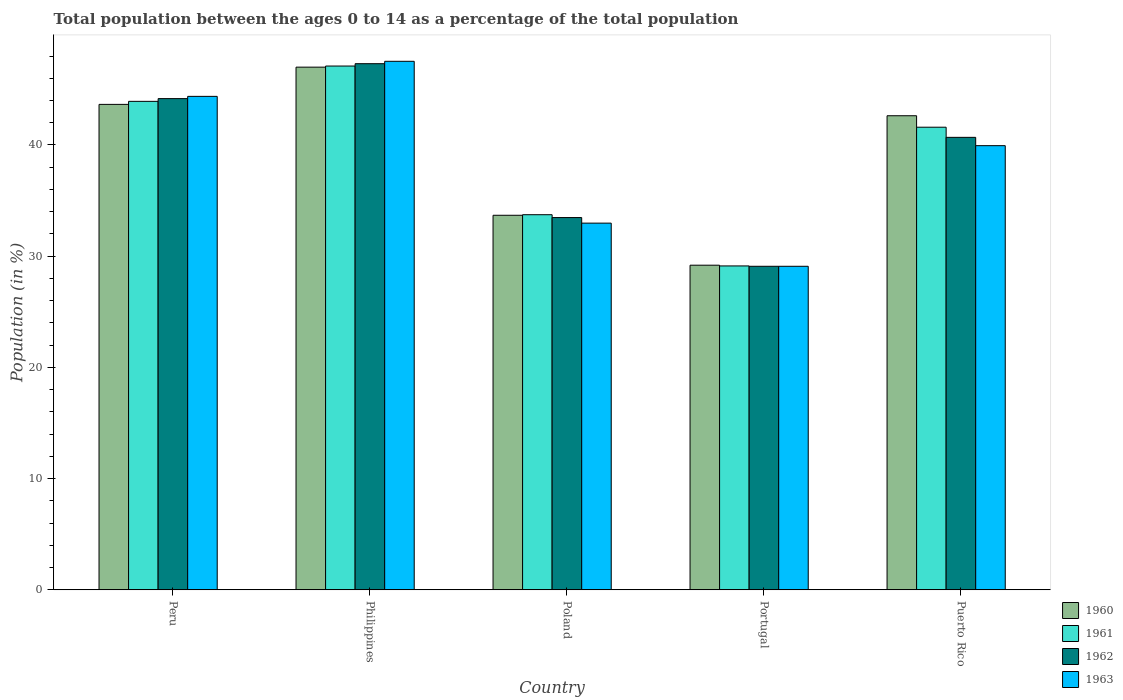How many different coloured bars are there?
Ensure brevity in your answer.  4. Are the number of bars per tick equal to the number of legend labels?
Keep it short and to the point. Yes. Are the number of bars on each tick of the X-axis equal?
Your answer should be compact. Yes. What is the label of the 1st group of bars from the left?
Your answer should be compact. Peru. In how many cases, is the number of bars for a given country not equal to the number of legend labels?
Provide a short and direct response. 0. What is the percentage of the population ages 0 to 14 in 1962 in Philippines?
Your answer should be very brief. 47.31. Across all countries, what is the maximum percentage of the population ages 0 to 14 in 1960?
Your answer should be compact. 47. Across all countries, what is the minimum percentage of the population ages 0 to 14 in 1961?
Ensure brevity in your answer.  29.13. In which country was the percentage of the population ages 0 to 14 in 1961 maximum?
Make the answer very short. Philippines. What is the total percentage of the population ages 0 to 14 in 1961 in the graph?
Provide a succinct answer. 195.48. What is the difference between the percentage of the population ages 0 to 14 in 1960 in Philippines and that in Portugal?
Give a very brief answer. 17.81. What is the difference between the percentage of the population ages 0 to 14 in 1960 in Puerto Rico and the percentage of the population ages 0 to 14 in 1963 in Peru?
Offer a very short reply. -1.74. What is the average percentage of the population ages 0 to 14 in 1962 per country?
Your response must be concise. 38.95. What is the difference between the percentage of the population ages 0 to 14 of/in 1963 and percentage of the population ages 0 to 14 of/in 1961 in Poland?
Provide a succinct answer. -0.76. In how many countries, is the percentage of the population ages 0 to 14 in 1960 greater than 10?
Give a very brief answer. 5. What is the ratio of the percentage of the population ages 0 to 14 in 1963 in Peru to that in Poland?
Make the answer very short. 1.35. Is the percentage of the population ages 0 to 14 in 1962 in Peru less than that in Portugal?
Give a very brief answer. No. What is the difference between the highest and the second highest percentage of the population ages 0 to 14 in 1963?
Ensure brevity in your answer.  4.43. What is the difference between the highest and the lowest percentage of the population ages 0 to 14 in 1963?
Ensure brevity in your answer.  18.43. What does the 4th bar from the left in Peru represents?
Your response must be concise. 1963. What does the 2nd bar from the right in Peru represents?
Ensure brevity in your answer.  1962. Is it the case that in every country, the sum of the percentage of the population ages 0 to 14 in 1962 and percentage of the population ages 0 to 14 in 1961 is greater than the percentage of the population ages 0 to 14 in 1963?
Give a very brief answer. Yes. What is the difference between two consecutive major ticks on the Y-axis?
Keep it short and to the point. 10. Are the values on the major ticks of Y-axis written in scientific E-notation?
Your response must be concise. No. Does the graph contain any zero values?
Give a very brief answer. No. Where does the legend appear in the graph?
Keep it short and to the point. Bottom right. How are the legend labels stacked?
Offer a very short reply. Vertical. What is the title of the graph?
Make the answer very short. Total population between the ages 0 to 14 as a percentage of the total population. Does "2011" appear as one of the legend labels in the graph?
Offer a very short reply. No. What is the label or title of the Y-axis?
Offer a terse response. Population (in %). What is the Population (in %) in 1960 in Peru?
Your answer should be very brief. 43.65. What is the Population (in %) in 1961 in Peru?
Give a very brief answer. 43.92. What is the Population (in %) in 1962 in Peru?
Ensure brevity in your answer.  44.17. What is the Population (in %) of 1963 in Peru?
Offer a terse response. 44.37. What is the Population (in %) in 1960 in Philippines?
Ensure brevity in your answer.  47. What is the Population (in %) of 1961 in Philippines?
Offer a very short reply. 47.1. What is the Population (in %) of 1962 in Philippines?
Make the answer very short. 47.31. What is the Population (in %) of 1963 in Philippines?
Make the answer very short. 47.53. What is the Population (in %) of 1960 in Poland?
Your answer should be compact. 33.68. What is the Population (in %) in 1961 in Poland?
Your answer should be compact. 33.73. What is the Population (in %) in 1962 in Poland?
Offer a terse response. 33.47. What is the Population (in %) in 1963 in Poland?
Offer a terse response. 32.97. What is the Population (in %) in 1960 in Portugal?
Offer a terse response. 29.19. What is the Population (in %) in 1961 in Portugal?
Offer a terse response. 29.13. What is the Population (in %) in 1962 in Portugal?
Provide a succinct answer. 29.09. What is the Population (in %) in 1963 in Portugal?
Your response must be concise. 29.09. What is the Population (in %) of 1960 in Puerto Rico?
Your answer should be very brief. 42.63. What is the Population (in %) in 1961 in Puerto Rico?
Give a very brief answer. 41.6. What is the Population (in %) in 1962 in Puerto Rico?
Offer a very short reply. 40.69. What is the Population (in %) of 1963 in Puerto Rico?
Make the answer very short. 39.94. Across all countries, what is the maximum Population (in %) in 1960?
Make the answer very short. 47. Across all countries, what is the maximum Population (in %) of 1961?
Offer a very short reply. 47.1. Across all countries, what is the maximum Population (in %) in 1962?
Provide a short and direct response. 47.31. Across all countries, what is the maximum Population (in %) in 1963?
Your response must be concise. 47.53. Across all countries, what is the minimum Population (in %) of 1960?
Provide a succinct answer. 29.19. Across all countries, what is the minimum Population (in %) in 1961?
Ensure brevity in your answer.  29.13. Across all countries, what is the minimum Population (in %) in 1962?
Your response must be concise. 29.09. Across all countries, what is the minimum Population (in %) in 1963?
Offer a terse response. 29.09. What is the total Population (in %) of 1960 in the graph?
Keep it short and to the point. 196.16. What is the total Population (in %) in 1961 in the graph?
Your response must be concise. 195.48. What is the total Population (in %) in 1962 in the graph?
Your answer should be very brief. 194.74. What is the total Population (in %) in 1963 in the graph?
Your answer should be very brief. 193.91. What is the difference between the Population (in %) in 1960 in Peru and that in Philippines?
Offer a terse response. -3.35. What is the difference between the Population (in %) of 1961 in Peru and that in Philippines?
Offer a very short reply. -3.18. What is the difference between the Population (in %) in 1962 in Peru and that in Philippines?
Ensure brevity in your answer.  -3.14. What is the difference between the Population (in %) of 1963 in Peru and that in Philippines?
Keep it short and to the point. -3.15. What is the difference between the Population (in %) in 1960 in Peru and that in Poland?
Make the answer very short. 9.97. What is the difference between the Population (in %) of 1961 in Peru and that in Poland?
Make the answer very short. 10.19. What is the difference between the Population (in %) of 1962 in Peru and that in Poland?
Give a very brief answer. 10.7. What is the difference between the Population (in %) of 1963 in Peru and that in Poland?
Provide a short and direct response. 11.4. What is the difference between the Population (in %) of 1960 in Peru and that in Portugal?
Offer a very short reply. 14.46. What is the difference between the Population (in %) of 1961 in Peru and that in Portugal?
Your answer should be compact. 14.8. What is the difference between the Population (in %) of 1962 in Peru and that in Portugal?
Provide a succinct answer. 15.08. What is the difference between the Population (in %) of 1963 in Peru and that in Portugal?
Ensure brevity in your answer.  15.28. What is the difference between the Population (in %) of 1960 in Peru and that in Puerto Rico?
Ensure brevity in your answer.  1.02. What is the difference between the Population (in %) of 1961 in Peru and that in Puerto Rico?
Your answer should be compact. 2.33. What is the difference between the Population (in %) in 1962 in Peru and that in Puerto Rico?
Ensure brevity in your answer.  3.48. What is the difference between the Population (in %) of 1963 in Peru and that in Puerto Rico?
Ensure brevity in your answer.  4.43. What is the difference between the Population (in %) in 1960 in Philippines and that in Poland?
Offer a terse response. 13.32. What is the difference between the Population (in %) in 1961 in Philippines and that in Poland?
Your answer should be very brief. 13.37. What is the difference between the Population (in %) of 1962 in Philippines and that in Poland?
Provide a short and direct response. 13.84. What is the difference between the Population (in %) in 1963 in Philippines and that in Poland?
Offer a terse response. 14.55. What is the difference between the Population (in %) in 1960 in Philippines and that in Portugal?
Ensure brevity in your answer.  17.81. What is the difference between the Population (in %) in 1961 in Philippines and that in Portugal?
Keep it short and to the point. 17.97. What is the difference between the Population (in %) in 1962 in Philippines and that in Portugal?
Ensure brevity in your answer.  18.22. What is the difference between the Population (in %) in 1963 in Philippines and that in Portugal?
Ensure brevity in your answer.  18.43. What is the difference between the Population (in %) of 1960 in Philippines and that in Puerto Rico?
Your answer should be compact. 4.37. What is the difference between the Population (in %) of 1961 in Philippines and that in Puerto Rico?
Your answer should be compact. 5.5. What is the difference between the Population (in %) of 1962 in Philippines and that in Puerto Rico?
Offer a very short reply. 6.62. What is the difference between the Population (in %) of 1963 in Philippines and that in Puerto Rico?
Your answer should be very brief. 7.59. What is the difference between the Population (in %) of 1960 in Poland and that in Portugal?
Ensure brevity in your answer.  4.49. What is the difference between the Population (in %) of 1961 in Poland and that in Portugal?
Your answer should be compact. 4.61. What is the difference between the Population (in %) of 1962 in Poland and that in Portugal?
Your answer should be very brief. 4.38. What is the difference between the Population (in %) in 1963 in Poland and that in Portugal?
Provide a short and direct response. 3.88. What is the difference between the Population (in %) of 1960 in Poland and that in Puerto Rico?
Your answer should be very brief. -8.95. What is the difference between the Population (in %) in 1961 in Poland and that in Puerto Rico?
Offer a terse response. -7.87. What is the difference between the Population (in %) in 1962 in Poland and that in Puerto Rico?
Your response must be concise. -7.21. What is the difference between the Population (in %) in 1963 in Poland and that in Puerto Rico?
Keep it short and to the point. -6.97. What is the difference between the Population (in %) in 1960 in Portugal and that in Puerto Rico?
Your response must be concise. -13.44. What is the difference between the Population (in %) in 1961 in Portugal and that in Puerto Rico?
Give a very brief answer. -12.47. What is the difference between the Population (in %) in 1962 in Portugal and that in Puerto Rico?
Give a very brief answer. -11.59. What is the difference between the Population (in %) in 1963 in Portugal and that in Puerto Rico?
Offer a terse response. -10.85. What is the difference between the Population (in %) of 1960 in Peru and the Population (in %) of 1961 in Philippines?
Your response must be concise. -3.45. What is the difference between the Population (in %) in 1960 in Peru and the Population (in %) in 1962 in Philippines?
Provide a succinct answer. -3.66. What is the difference between the Population (in %) of 1960 in Peru and the Population (in %) of 1963 in Philippines?
Give a very brief answer. -3.87. What is the difference between the Population (in %) in 1961 in Peru and the Population (in %) in 1962 in Philippines?
Offer a terse response. -3.39. What is the difference between the Population (in %) of 1961 in Peru and the Population (in %) of 1963 in Philippines?
Your response must be concise. -3.6. What is the difference between the Population (in %) of 1962 in Peru and the Population (in %) of 1963 in Philippines?
Your answer should be compact. -3.36. What is the difference between the Population (in %) in 1960 in Peru and the Population (in %) in 1961 in Poland?
Provide a succinct answer. 9.92. What is the difference between the Population (in %) in 1960 in Peru and the Population (in %) in 1962 in Poland?
Provide a succinct answer. 10.18. What is the difference between the Population (in %) of 1960 in Peru and the Population (in %) of 1963 in Poland?
Provide a short and direct response. 10.68. What is the difference between the Population (in %) of 1961 in Peru and the Population (in %) of 1962 in Poland?
Your response must be concise. 10.45. What is the difference between the Population (in %) of 1961 in Peru and the Population (in %) of 1963 in Poland?
Make the answer very short. 10.95. What is the difference between the Population (in %) of 1962 in Peru and the Population (in %) of 1963 in Poland?
Make the answer very short. 11.2. What is the difference between the Population (in %) in 1960 in Peru and the Population (in %) in 1961 in Portugal?
Keep it short and to the point. 14.53. What is the difference between the Population (in %) in 1960 in Peru and the Population (in %) in 1962 in Portugal?
Your response must be concise. 14.56. What is the difference between the Population (in %) of 1960 in Peru and the Population (in %) of 1963 in Portugal?
Keep it short and to the point. 14.56. What is the difference between the Population (in %) in 1961 in Peru and the Population (in %) in 1962 in Portugal?
Your answer should be compact. 14.83. What is the difference between the Population (in %) of 1961 in Peru and the Population (in %) of 1963 in Portugal?
Offer a very short reply. 14.83. What is the difference between the Population (in %) of 1962 in Peru and the Population (in %) of 1963 in Portugal?
Your answer should be compact. 15.08. What is the difference between the Population (in %) of 1960 in Peru and the Population (in %) of 1961 in Puerto Rico?
Your answer should be very brief. 2.05. What is the difference between the Population (in %) of 1960 in Peru and the Population (in %) of 1962 in Puerto Rico?
Your answer should be very brief. 2.96. What is the difference between the Population (in %) of 1960 in Peru and the Population (in %) of 1963 in Puerto Rico?
Offer a terse response. 3.71. What is the difference between the Population (in %) of 1961 in Peru and the Population (in %) of 1962 in Puerto Rico?
Offer a very short reply. 3.24. What is the difference between the Population (in %) in 1961 in Peru and the Population (in %) in 1963 in Puerto Rico?
Your response must be concise. 3.98. What is the difference between the Population (in %) in 1962 in Peru and the Population (in %) in 1963 in Puerto Rico?
Offer a very short reply. 4.23. What is the difference between the Population (in %) in 1960 in Philippines and the Population (in %) in 1961 in Poland?
Provide a succinct answer. 13.27. What is the difference between the Population (in %) of 1960 in Philippines and the Population (in %) of 1962 in Poland?
Make the answer very short. 13.53. What is the difference between the Population (in %) in 1960 in Philippines and the Population (in %) in 1963 in Poland?
Your answer should be compact. 14.03. What is the difference between the Population (in %) of 1961 in Philippines and the Population (in %) of 1962 in Poland?
Offer a terse response. 13.63. What is the difference between the Population (in %) in 1961 in Philippines and the Population (in %) in 1963 in Poland?
Your answer should be very brief. 14.13. What is the difference between the Population (in %) of 1962 in Philippines and the Population (in %) of 1963 in Poland?
Ensure brevity in your answer.  14.34. What is the difference between the Population (in %) in 1960 in Philippines and the Population (in %) in 1961 in Portugal?
Make the answer very short. 17.88. What is the difference between the Population (in %) of 1960 in Philippines and the Population (in %) of 1962 in Portugal?
Your answer should be very brief. 17.91. What is the difference between the Population (in %) in 1960 in Philippines and the Population (in %) in 1963 in Portugal?
Give a very brief answer. 17.91. What is the difference between the Population (in %) of 1961 in Philippines and the Population (in %) of 1962 in Portugal?
Ensure brevity in your answer.  18.01. What is the difference between the Population (in %) in 1961 in Philippines and the Population (in %) in 1963 in Portugal?
Offer a terse response. 18.01. What is the difference between the Population (in %) in 1962 in Philippines and the Population (in %) in 1963 in Portugal?
Your answer should be compact. 18.22. What is the difference between the Population (in %) in 1960 in Philippines and the Population (in %) in 1961 in Puerto Rico?
Your answer should be compact. 5.4. What is the difference between the Population (in %) in 1960 in Philippines and the Population (in %) in 1962 in Puerto Rico?
Offer a terse response. 6.31. What is the difference between the Population (in %) of 1960 in Philippines and the Population (in %) of 1963 in Puerto Rico?
Provide a succinct answer. 7.06. What is the difference between the Population (in %) of 1961 in Philippines and the Population (in %) of 1962 in Puerto Rico?
Provide a succinct answer. 6.41. What is the difference between the Population (in %) in 1961 in Philippines and the Population (in %) in 1963 in Puerto Rico?
Provide a succinct answer. 7.16. What is the difference between the Population (in %) in 1962 in Philippines and the Population (in %) in 1963 in Puerto Rico?
Your answer should be compact. 7.37. What is the difference between the Population (in %) in 1960 in Poland and the Population (in %) in 1961 in Portugal?
Your answer should be very brief. 4.56. What is the difference between the Population (in %) in 1960 in Poland and the Population (in %) in 1962 in Portugal?
Provide a succinct answer. 4.59. What is the difference between the Population (in %) of 1960 in Poland and the Population (in %) of 1963 in Portugal?
Offer a terse response. 4.59. What is the difference between the Population (in %) in 1961 in Poland and the Population (in %) in 1962 in Portugal?
Offer a very short reply. 4.64. What is the difference between the Population (in %) in 1961 in Poland and the Population (in %) in 1963 in Portugal?
Offer a very short reply. 4.64. What is the difference between the Population (in %) in 1962 in Poland and the Population (in %) in 1963 in Portugal?
Your answer should be compact. 4.38. What is the difference between the Population (in %) of 1960 in Poland and the Population (in %) of 1961 in Puerto Rico?
Your response must be concise. -7.92. What is the difference between the Population (in %) in 1960 in Poland and the Population (in %) in 1962 in Puerto Rico?
Your answer should be compact. -7.01. What is the difference between the Population (in %) in 1960 in Poland and the Population (in %) in 1963 in Puerto Rico?
Provide a short and direct response. -6.26. What is the difference between the Population (in %) of 1961 in Poland and the Population (in %) of 1962 in Puerto Rico?
Your answer should be compact. -6.96. What is the difference between the Population (in %) in 1961 in Poland and the Population (in %) in 1963 in Puerto Rico?
Offer a terse response. -6.21. What is the difference between the Population (in %) of 1962 in Poland and the Population (in %) of 1963 in Puerto Rico?
Offer a very short reply. -6.47. What is the difference between the Population (in %) in 1960 in Portugal and the Population (in %) in 1961 in Puerto Rico?
Offer a terse response. -12.41. What is the difference between the Population (in %) in 1960 in Portugal and the Population (in %) in 1962 in Puerto Rico?
Your answer should be compact. -11.5. What is the difference between the Population (in %) of 1960 in Portugal and the Population (in %) of 1963 in Puerto Rico?
Provide a short and direct response. -10.75. What is the difference between the Population (in %) in 1961 in Portugal and the Population (in %) in 1962 in Puerto Rico?
Your answer should be compact. -11.56. What is the difference between the Population (in %) in 1961 in Portugal and the Population (in %) in 1963 in Puerto Rico?
Give a very brief answer. -10.81. What is the difference between the Population (in %) of 1962 in Portugal and the Population (in %) of 1963 in Puerto Rico?
Keep it short and to the point. -10.85. What is the average Population (in %) in 1960 per country?
Provide a short and direct response. 39.23. What is the average Population (in %) in 1961 per country?
Ensure brevity in your answer.  39.1. What is the average Population (in %) in 1962 per country?
Your response must be concise. 38.95. What is the average Population (in %) of 1963 per country?
Your answer should be compact. 38.78. What is the difference between the Population (in %) in 1960 and Population (in %) in 1961 in Peru?
Ensure brevity in your answer.  -0.27. What is the difference between the Population (in %) of 1960 and Population (in %) of 1962 in Peru?
Ensure brevity in your answer.  -0.52. What is the difference between the Population (in %) in 1960 and Population (in %) in 1963 in Peru?
Provide a short and direct response. -0.72. What is the difference between the Population (in %) in 1961 and Population (in %) in 1962 in Peru?
Give a very brief answer. -0.25. What is the difference between the Population (in %) in 1961 and Population (in %) in 1963 in Peru?
Your answer should be very brief. -0.45. What is the difference between the Population (in %) in 1962 and Population (in %) in 1963 in Peru?
Provide a short and direct response. -0.2. What is the difference between the Population (in %) in 1960 and Population (in %) in 1961 in Philippines?
Provide a short and direct response. -0.1. What is the difference between the Population (in %) in 1960 and Population (in %) in 1962 in Philippines?
Your response must be concise. -0.31. What is the difference between the Population (in %) in 1960 and Population (in %) in 1963 in Philippines?
Keep it short and to the point. -0.53. What is the difference between the Population (in %) in 1961 and Population (in %) in 1962 in Philippines?
Your response must be concise. -0.21. What is the difference between the Population (in %) of 1961 and Population (in %) of 1963 in Philippines?
Keep it short and to the point. -0.43. What is the difference between the Population (in %) in 1962 and Population (in %) in 1963 in Philippines?
Offer a very short reply. -0.21. What is the difference between the Population (in %) in 1960 and Population (in %) in 1961 in Poland?
Ensure brevity in your answer.  -0.05. What is the difference between the Population (in %) in 1960 and Population (in %) in 1962 in Poland?
Make the answer very short. 0.21. What is the difference between the Population (in %) in 1960 and Population (in %) in 1963 in Poland?
Your answer should be very brief. 0.71. What is the difference between the Population (in %) in 1961 and Population (in %) in 1962 in Poland?
Your answer should be compact. 0.26. What is the difference between the Population (in %) in 1961 and Population (in %) in 1963 in Poland?
Offer a terse response. 0.76. What is the difference between the Population (in %) in 1962 and Population (in %) in 1963 in Poland?
Offer a very short reply. 0.5. What is the difference between the Population (in %) in 1960 and Population (in %) in 1961 in Portugal?
Offer a terse response. 0.07. What is the difference between the Population (in %) in 1960 and Population (in %) in 1962 in Portugal?
Offer a very short reply. 0.1. What is the difference between the Population (in %) in 1960 and Population (in %) in 1963 in Portugal?
Keep it short and to the point. 0.1. What is the difference between the Population (in %) in 1961 and Population (in %) in 1962 in Portugal?
Make the answer very short. 0.03. What is the difference between the Population (in %) of 1961 and Population (in %) of 1963 in Portugal?
Keep it short and to the point. 0.03. What is the difference between the Population (in %) of 1962 and Population (in %) of 1963 in Portugal?
Keep it short and to the point. 0. What is the difference between the Population (in %) of 1960 and Population (in %) of 1961 in Puerto Rico?
Provide a short and direct response. 1.03. What is the difference between the Population (in %) in 1960 and Population (in %) in 1962 in Puerto Rico?
Keep it short and to the point. 1.94. What is the difference between the Population (in %) in 1960 and Population (in %) in 1963 in Puerto Rico?
Ensure brevity in your answer.  2.69. What is the difference between the Population (in %) of 1961 and Population (in %) of 1962 in Puerto Rico?
Provide a succinct answer. 0.91. What is the difference between the Population (in %) of 1961 and Population (in %) of 1963 in Puerto Rico?
Your answer should be compact. 1.66. What is the difference between the Population (in %) in 1962 and Population (in %) in 1963 in Puerto Rico?
Your answer should be very brief. 0.75. What is the ratio of the Population (in %) of 1960 in Peru to that in Philippines?
Provide a succinct answer. 0.93. What is the ratio of the Population (in %) of 1961 in Peru to that in Philippines?
Offer a terse response. 0.93. What is the ratio of the Population (in %) of 1962 in Peru to that in Philippines?
Your response must be concise. 0.93. What is the ratio of the Population (in %) of 1963 in Peru to that in Philippines?
Make the answer very short. 0.93. What is the ratio of the Population (in %) of 1960 in Peru to that in Poland?
Provide a succinct answer. 1.3. What is the ratio of the Population (in %) in 1961 in Peru to that in Poland?
Provide a succinct answer. 1.3. What is the ratio of the Population (in %) in 1962 in Peru to that in Poland?
Provide a short and direct response. 1.32. What is the ratio of the Population (in %) of 1963 in Peru to that in Poland?
Keep it short and to the point. 1.35. What is the ratio of the Population (in %) in 1960 in Peru to that in Portugal?
Provide a short and direct response. 1.5. What is the ratio of the Population (in %) in 1961 in Peru to that in Portugal?
Your response must be concise. 1.51. What is the ratio of the Population (in %) of 1962 in Peru to that in Portugal?
Provide a short and direct response. 1.52. What is the ratio of the Population (in %) of 1963 in Peru to that in Portugal?
Provide a short and direct response. 1.53. What is the ratio of the Population (in %) in 1961 in Peru to that in Puerto Rico?
Your answer should be very brief. 1.06. What is the ratio of the Population (in %) of 1962 in Peru to that in Puerto Rico?
Provide a succinct answer. 1.09. What is the ratio of the Population (in %) of 1963 in Peru to that in Puerto Rico?
Provide a short and direct response. 1.11. What is the ratio of the Population (in %) of 1960 in Philippines to that in Poland?
Your answer should be very brief. 1.4. What is the ratio of the Population (in %) of 1961 in Philippines to that in Poland?
Offer a terse response. 1.4. What is the ratio of the Population (in %) of 1962 in Philippines to that in Poland?
Offer a very short reply. 1.41. What is the ratio of the Population (in %) of 1963 in Philippines to that in Poland?
Offer a terse response. 1.44. What is the ratio of the Population (in %) in 1960 in Philippines to that in Portugal?
Ensure brevity in your answer.  1.61. What is the ratio of the Population (in %) in 1961 in Philippines to that in Portugal?
Make the answer very short. 1.62. What is the ratio of the Population (in %) in 1962 in Philippines to that in Portugal?
Ensure brevity in your answer.  1.63. What is the ratio of the Population (in %) of 1963 in Philippines to that in Portugal?
Your answer should be compact. 1.63. What is the ratio of the Population (in %) of 1960 in Philippines to that in Puerto Rico?
Keep it short and to the point. 1.1. What is the ratio of the Population (in %) in 1961 in Philippines to that in Puerto Rico?
Keep it short and to the point. 1.13. What is the ratio of the Population (in %) of 1962 in Philippines to that in Puerto Rico?
Offer a terse response. 1.16. What is the ratio of the Population (in %) of 1963 in Philippines to that in Puerto Rico?
Provide a succinct answer. 1.19. What is the ratio of the Population (in %) of 1960 in Poland to that in Portugal?
Ensure brevity in your answer.  1.15. What is the ratio of the Population (in %) of 1961 in Poland to that in Portugal?
Your response must be concise. 1.16. What is the ratio of the Population (in %) of 1962 in Poland to that in Portugal?
Give a very brief answer. 1.15. What is the ratio of the Population (in %) in 1963 in Poland to that in Portugal?
Keep it short and to the point. 1.13. What is the ratio of the Population (in %) of 1960 in Poland to that in Puerto Rico?
Give a very brief answer. 0.79. What is the ratio of the Population (in %) of 1961 in Poland to that in Puerto Rico?
Give a very brief answer. 0.81. What is the ratio of the Population (in %) in 1962 in Poland to that in Puerto Rico?
Give a very brief answer. 0.82. What is the ratio of the Population (in %) in 1963 in Poland to that in Puerto Rico?
Ensure brevity in your answer.  0.83. What is the ratio of the Population (in %) in 1960 in Portugal to that in Puerto Rico?
Ensure brevity in your answer.  0.68. What is the ratio of the Population (in %) of 1961 in Portugal to that in Puerto Rico?
Provide a short and direct response. 0.7. What is the ratio of the Population (in %) in 1962 in Portugal to that in Puerto Rico?
Keep it short and to the point. 0.71. What is the ratio of the Population (in %) of 1963 in Portugal to that in Puerto Rico?
Your answer should be very brief. 0.73. What is the difference between the highest and the second highest Population (in %) of 1960?
Give a very brief answer. 3.35. What is the difference between the highest and the second highest Population (in %) of 1961?
Provide a short and direct response. 3.18. What is the difference between the highest and the second highest Population (in %) in 1962?
Keep it short and to the point. 3.14. What is the difference between the highest and the second highest Population (in %) in 1963?
Ensure brevity in your answer.  3.15. What is the difference between the highest and the lowest Population (in %) of 1960?
Offer a very short reply. 17.81. What is the difference between the highest and the lowest Population (in %) of 1961?
Give a very brief answer. 17.97. What is the difference between the highest and the lowest Population (in %) in 1962?
Your response must be concise. 18.22. What is the difference between the highest and the lowest Population (in %) of 1963?
Your answer should be compact. 18.43. 